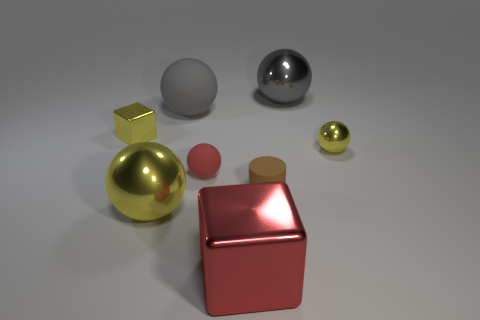There is a tiny matte thing that is the same shape as the large yellow object; what color is it?
Keep it short and to the point. Red. How many small balls are the same color as the tiny block?
Your answer should be very brief. 1. There is a tiny shiny thing that is right of the tiny brown thing; does it have the same shape as the gray rubber object?
Provide a succinct answer. Yes. There is a large red object in front of the large shiny object right of the metal thing in front of the big yellow metal thing; what is its shape?
Your answer should be very brief. Cube. What size is the gray metal object?
Your answer should be very brief. Large. What is the color of the large sphere that is the same material as the small red object?
Give a very brief answer. Gray. What number of big yellow balls are made of the same material as the red sphere?
Offer a very short reply. 0. There is a tiny shiny block; is it the same color as the ball that is left of the big matte thing?
Your response must be concise. Yes. The cube to the left of the red thing that is in front of the tiny brown object is what color?
Offer a very short reply. Yellow. What is the color of the rubber object that is the same size as the gray metallic sphere?
Provide a short and direct response. Gray. 